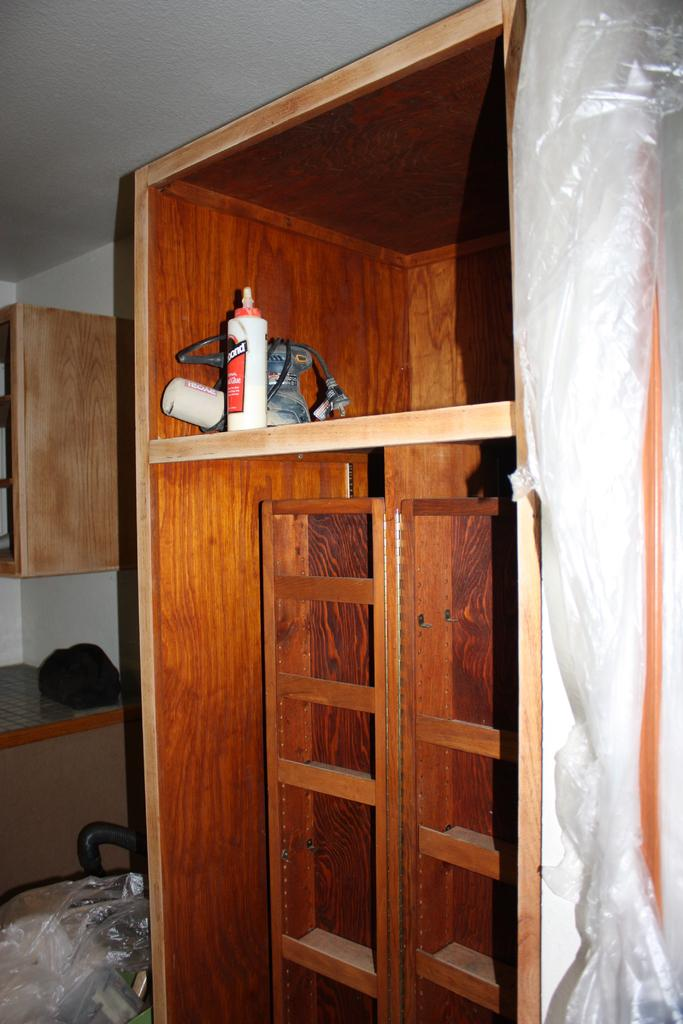What type of material is the wooden object made of in the image? The wooden object in the image is made of wood. What can be seen on the rack in the image? There are items on a rack in the image. What else can be seen in the image besides the wooden object and the rack? There are additional items visible in the background. What part of the room can be seen above the wooden object and the rack? The ceiling is visible in the image. How many leaves are on the wooden object in the image? There are no leaves present on the wooden object in the image. What type of base is supporting the wooden object in the image? The wooden object does not appear to be resting on a base in the image. 